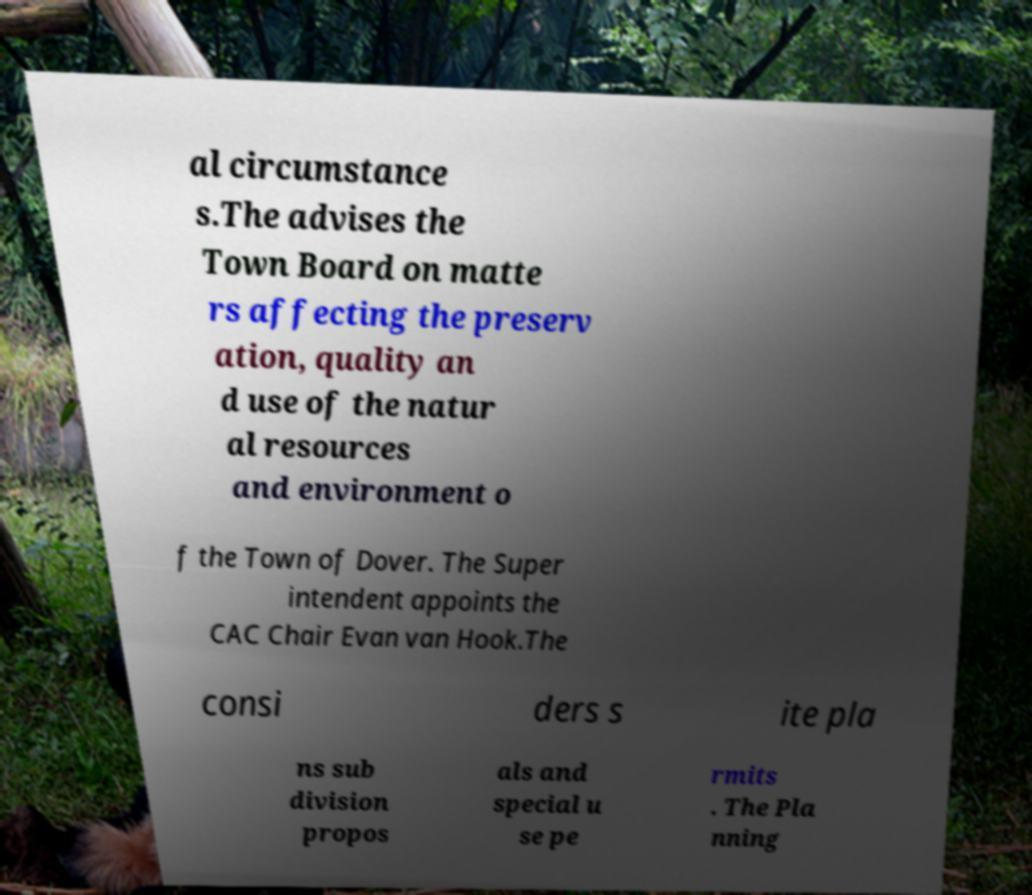Can you read and provide the text displayed in the image?This photo seems to have some interesting text. Can you extract and type it out for me? al circumstance s.The advises the Town Board on matte rs affecting the preserv ation, quality an d use of the natur al resources and environment o f the Town of Dover. The Super intendent appoints the CAC Chair Evan van Hook.The consi ders s ite pla ns sub division propos als and special u se pe rmits . The Pla nning 